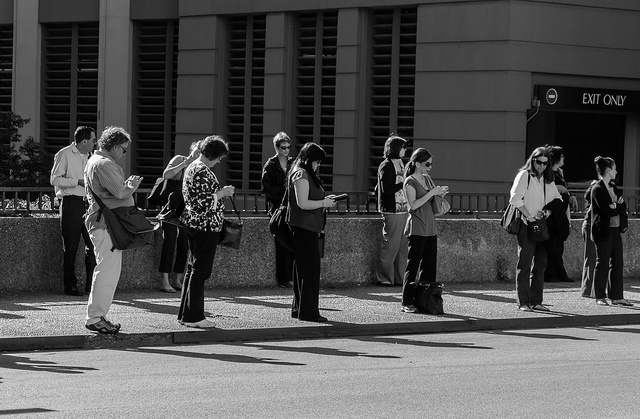Describe the objects in this image and their specific colors. I can see people in black, gray, darkgray, and lightgray tones, people in black, gray, darkgray, and lightgray tones, people in black, gray, and lightgray tones, people in black, darkgray, gray, and lightgray tones, and people in black, darkgray, gray, and lightgray tones in this image. 